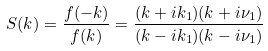<formula> <loc_0><loc_0><loc_500><loc_500>S ( k ) = \frac { f ( - k ) } { f ( k ) } = \frac { ( k + i k _ { 1 } ) ( k + i \nu _ { 1 } ) } { ( k - i k _ { 1 } ) ( k - i \nu _ { 1 } ) }</formula> 